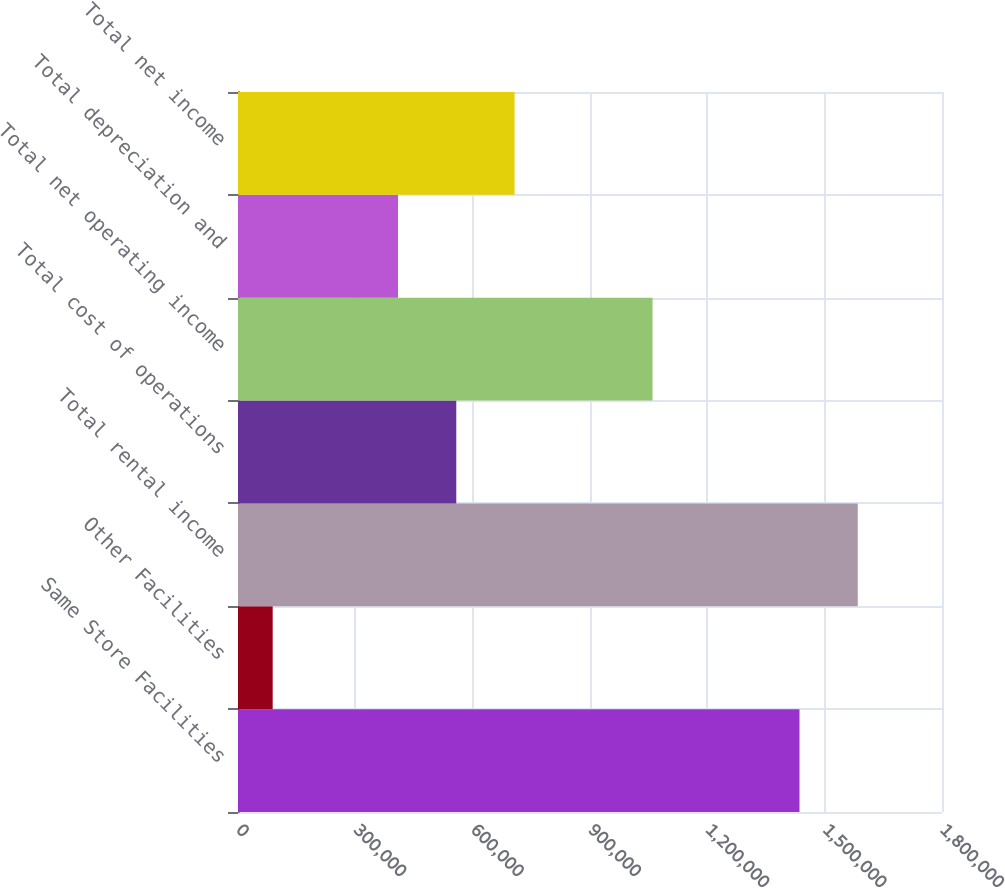Convert chart. <chart><loc_0><loc_0><loc_500><loc_500><bar_chart><fcel>Same Store Facilities<fcel>Other Facilities<fcel>Total rental income<fcel>Total cost of operations<fcel>Total net operating income<fcel>Total depreciation and<fcel>Total net income<nl><fcel>1.43563e+06<fcel>88665<fcel>1.58467e+06<fcel>558116<fcel>1.05993e+06<fcel>409081<fcel>707151<nl></chart> 